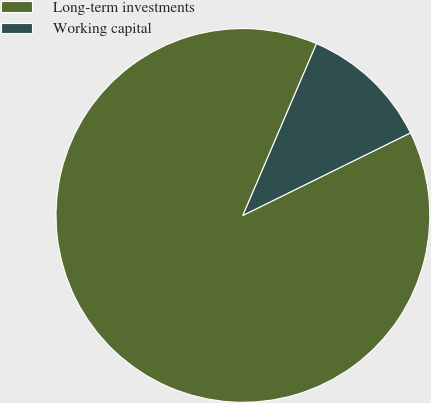<chart> <loc_0><loc_0><loc_500><loc_500><pie_chart><fcel>Long-term investments<fcel>Working capital<nl><fcel>88.73%<fcel>11.27%<nl></chart> 